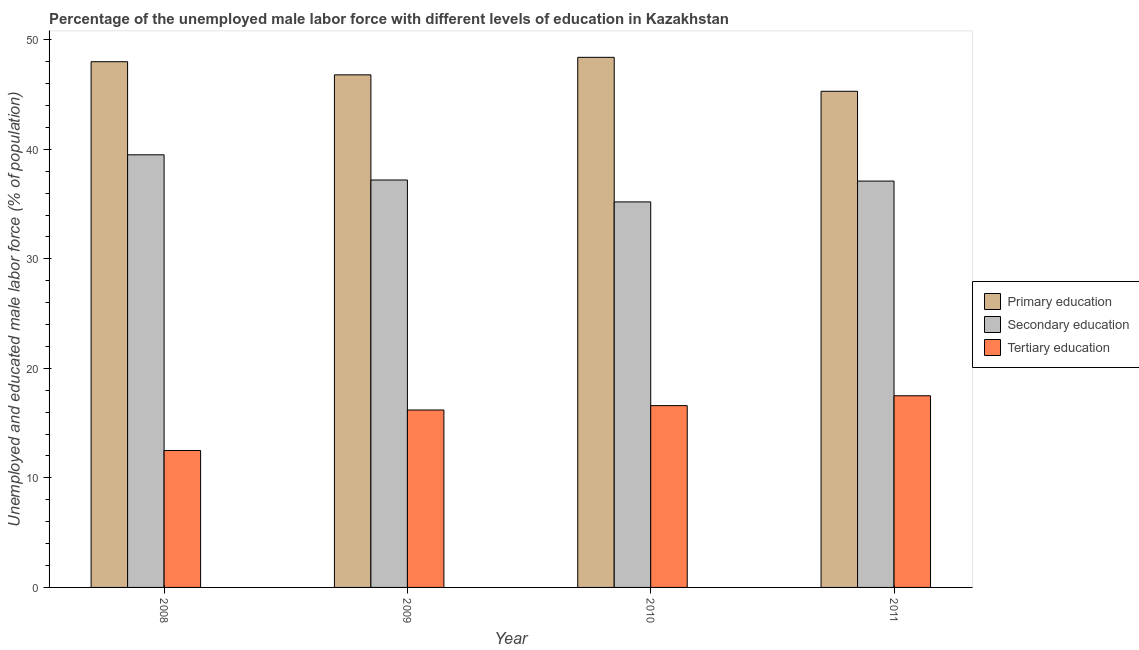How many different coloured bars are there?
Make the answer very short. 3. How many groups of bars are there?
Your answer should be very brief. 4. Are the number of bars per tick equal to the number of legend labels?
Offer a very short reply. Yes. How many bars are there on the 2nd tick from the left?
Your answer should be very brief. 3. How many bars are there on the 3rd tick from the right?
Offer a terse response. 3. In how many cases, is the number of bars for a given year not equal to the number of legend labels?
Your answer should be very brief. 0. What is the percentage of male labor force who received tertiary education in 2008?
Your response must be concise. 12.5. Across all years, what is the maximum percentage of male labor force who received tertiary education?
Ensure brevity in your answer.  17.5. Across all years, what is the minimum percentage of male labor force who received secondary education?
Your response must be concise. 35.2. What is the total percentage of male labor force who received primary education in the graph?
Your answer should be very brief. 188.5. What is the difference between the percentage of male labor force who received primary education in 2008 and that in 2009?
Ensure brevity in your answer.  1.2. What is the difference between the percentage of male labor force who received primary education in 2010 and the percentage of male labor force who received tertiary education in 2011?
Offer a terse response. 3.1. What is the average percentage of male labor force who received secondary education per year?
Ensure brevity in your answer.  37.25. What is the ratio of the percentage of male labor force who received tertiary education in 2009 to that in 2011?
Give a very brief answer. 0.93. Is the difference between the percentage of male labor force who received primary education in 2008 and 2011 greater than the difference between the percentage of male labor force who received tertiary education in 2008 and 2011?
Your answer should be compact. No. What is the difference between the highest and the second highest percentage of male labor force who received secondary education?
Provide a short and direct response. 2.3. What is the difference between the highest and the lowest percentage of male labor force who received secondary education?
Offer a very short reply. 4.3. What does the 3rd bar from the left in 2008 represents?
Ensure brevity in your answer.  Tertiary education. What does the 1st bar from the right in 2011 represents?
Make the answer very short. Tertiary education. Are all the bars in the graph horizontal?
Provide a succinct answer. No. How many years are there in the graph?
Provide a succinct answer. 4. Are the values on the major ticks of Y-axis written in scientific E-notation?
Ensure brevity in your answer.  No. Does the graph contain any zero values?
Make the answer very short. No. How are the legend labels stacked?
Your answer should be very brief. Vertical. What is the title of the graph?
Give a very brief answer. Percentage of the unemployed male labor force with different levels of education in Kazakhstan. Does "Wage workers" appear as one of the legend labels in the graph?
Ensure brevity in your answer.  No. What is the label or title of the X-axis?
Your answer should be very brief. Year. What is the label or title of the Y-axis?
Your answer should be very brief. Unemployed and educated male labor force (% of population). What is the Unemployed and educated male labor force (% of population) of Primary education in 2008?
Provide a succinct answer. 48. What is the Unemployed and educated male labor force (% of population) in Secondary education in 2008?
Ensure brevity in your answer.  39.5. What is the Unemployed and educated male labor force (% of population) in Tertiary education in 2008?
Give a very brief answer. 12.5. What is the Unemployed and educated male labor force (% of population) of Primary education in 2009?
Give a very brief answer. 46.8. What is the Unemployed and educated male labor force (% of population) of Secondary education in 2009?
Keep it short and to the point. 37.2. What is the Unemployed and educated male labor force (% of population) in Tertiary education in 2009?
Provide a succinct answer. 16.2. What is the Unemployed and educated male labor force (% of population) of Primary education in 2010?
Keep it short and to the point. 48.4. What is the Unemployed and educated male labor force (% of population) of Secondary education in 2010?
Your response must be concise. 35.2. What is the Unemployed and educated male labor force (% of population) of Tertiary education in 2010?
Your answer should be compact. 16.6. What is the Unemployed and educated male labor force (% of population) of Primary education in 2011?
Your answer should be very brief. 45.3. What is the Unemployed and educated male labor force (% of population) of Secondary education in 2011?
Give a very brief answer. 37.1. Across all years, what is the maximum Unemployed and educated male labor force (% of population) in Primary education?
Make the answer very short. 48.4. Across all years, what is the maximum Unemployed and educated male labor force (% of population) of Secondary education?
Provide a succinct answer. 39.5. Across all years, what is the minimum Unemployed and educated male labor force (% of population) in Primary education?
Keep it short and to the point. 45.3. Across all years, what is the minimum Unemployed and educated male labor force (% of population) in Secondary education?
Your response must be concise. 35.2. What is the total Unemployed and educated male labor force (% of population) in Primary education in the graph?
Your answer should be very brief. 188.5. What is the total Unemployed and educated male labor force (% of population) in Secondary education in the graph?
Give a very brief answer. 149. What is the total Unemployed and educated male labor force (% of population) of Tertiary education in the graph?
Keep it short and to the point. 62.8. What is the difference between the Unemployed and educated male labor force (% of population) in Tertiary education in 2008 and that in 2009?
Make the answer very short. -3.7. What is the difference between the Unemployed and educated male labor force (% of population) in Primary education in 2008 and that in 2010?
Offer a terse response. -0.4. What is the difference between the Unemployed and educated male labor force (% of population) of Tertiary education in 2008 and that in 2010?
Offer a terse response. -4.1. What is the difference between the Unemployed and educated male labor force (% of population) in Secondary education in 2008 and that in 2011?
Your answer should be compact. 2.4. What is the difference between the Unemployed and educated male labor force (% of population) in Tertiary education in 2008 and that in 2011?
Keep it short and to the point. -5. What is the difference between the Unemployed and educated male labor force (% of population) of Primary education in 2009 and that in 2010?
Make the answer very short. -1.6. What is the difference between the Unemployed and educated male labor force (% of population) of Primary education in 2009 and that in 2011?
Offer a terse response. 1.5. What is the difference between the Unemployed and educated male labor force (% of population) in Secondary education in 2009 and that in 2011?
Offer a terse response. 0.1. What is the difference between the Unemployed and educated male labor force (% of population) in Primary education in 2010 and that in 2011?
Offer a very short reply. 3.1. What is the difference between the Unemployed and educated male labor force (% of population) in Tertiary education in 2010 and that in 2011?
Provide a succinct answer. -0.9. What is the difference between the Unemployed and educated male labor force (% of population) in Primary education in 2008 and the Unemployed and educated male labor force (% of population) in Tertiary education in 2009?
Provide a short and direct response. 31.8. What is the difference between the Unemployed and educated male labor force (% of population) of Secondary education in 2008 and the Unemployed and educated male labor force (% of population) of Tertiary education in 2009?
Give a very brief answer. 23.3. What is the difference between the Unemployed and educated male labor force (% of population) in Primary education in 2008 and the Unemployed and educated male labor force (% of population) in Secondary education in 2010?
Make the answer very short. 12.8. What is the difference between the Unemployed and educated male labor force (% of population) of Primary education in 2008 and the Unemployed and educated male labor force (% of population) of Tertiary education in 2010?
Offer a very short reply. 31.4. What is the difference between the Unemployed and educated male labor force (% of population) in Secondary education in 2008 and the Unemployed and educated male labor force (% of population) in Tertiary education in 2010?
Make the answer very short. 22.9. What is the difference between the Unemployed and educated male labor force (% of population) in Primary education in 2008 and the Unemployed and educated male labor force (% of population) in Tertiary education in 2011?
Your response must be concise. 30.5. What is the difference between the Unemployed and educated male labor force (% of population) of Secondary education in 2008 and the Unemployed and educated male labor force (% of population) of Tertiary education in 2011?
Your answer should be compact. 22. What is the difference between the Unemployed and educated male labor force (% of population) in Primary education in 2009 and the Unemployed and educated male labor force (% of population) in Tertiary education in 2010?
Offer a terse response. 30.2. What is the difference between the Unemployed and educated male labor force (% of population) of Secondary education in 2009 and the Unemployed and educated male labor force (% of population) of Tertiary education in 2010?
Provide a succinct answer. 20.6. What is the difference between the Unemployed and educated male labor force (% of population) of Primary education in 2009 and the Unemployed and educated male labor force (% of population) of Secondary education in 2011?
Provide a succinct answer. 9.7. What is the difference between the Unemployed and educated male labor force (% of population) of Primary education in 2009 and the Unemployed and educated male labor force (% of population) of Tertiary education in 2011?
Ensure brevity in your answer.  29.3. What is the difference between the Unemployed and educated male labor force (% of population) in Secondary education in 2009 and the Unemployed and educated male labor force (% of population) in Tertiary education in 2011?
Ensure brevity in your answer.  19.7. What is the difference between the Unemployed and educated male labor force (% of population) of Primary education in 2010 and the Unemployed and educated male labor force (% of population) of Secondary education in 2011?
Offer a terse response. 11.3. What is the difference between the Unemployed and educated male labor force (% of population) of Primary education in 2010 and the Unemployed and educated male labor force (% of population) of Tertiary education in 2011?
Give a very brief answer. 30.9. What is the average Unemployed and educated male labor force (% of population) of Primary education per year?
Ensure brevity in your answer.  47.12. What is the average Unemployed and educated male labor force (% of population) in Secondary education per year?
Offer a terse response. 37.25. In the year 2008, what is the difference between the Unemployed and educated male labor force (% of population) of Primary education and Unemployed and educated male labor force (% of population) of Tertiary education?
Your answer should be very brief. 35.5. In the year 2008, what is the difference between the Unemployed and educated male labor force (% of population) of Secondary education and Unemployed and educated male labor force (% of population) of Tertiary education?
Offer a very short reply. 27. In the year 2009, what is the difference between the Unemployed and educated male labor force (% of population) in Primary education and Unemployed and educated male labor force (% of population) in Tertiary education?
Make the answer very short. 30.6. In the year 2010, what is the difference between the Unemployed and educated male labor force (% of population) of Primary education and Unemployed and educated male labor force (% of population) of Secondary education?
Offer a terse response. 13.2. In the year 2010, what is the difference between the Unemployed and educated male labor force (% of population) of Primary education and Unemployed and educated male labor force (% of population) of Tertiary education?
Provide a succinct answer. 31.8. In the year 2010, what is the difference between the Unemployed and educated male labor force (% of population) of Secondary education and Unemployed and educated male labor force (% of population) of Tertiary education?
Your response must be concise. 18.6. In the year 2011, what is the difference between the Unemployed and educated male labor force (% of population) in Primary education and Unemployed and educated male labor force (% of population) in Secondary education?
Make the answer very short. 8.2. In the year 2011, what is the difference between the Unemployed and educated male labor force (% of population) in Primary education and Unemployed and educated male labor force (% of population) in Tertiary education?
Your answer should be compact. 27.8. In the year 2011, what is the difference between the Unemployed and educated male labor force (% of population) in Secondary education and Unemployed and educated male labor force (% of population) in Tertiary education?
Offer a very short reply. 19.6. What is the ratio of the Unemployed and educated male labor force (% of population) in Primary education in 2008 to that in 2009?
Your answer should be very brief. 1.03. What is the ratio of the Unemployed and educated male labor force (% of population) in Secondary education in 2008 to that in 2009?
Give a very brief answer. 1.06. What is the ratio of the Unemployed and educated male labor force (% of population) of Tertiary education in 2008 to that in 2009?
Make the answer very short. 0.77. What is the ratio of the Unemployed and educated male labor force (% of population) of Primary education in 2008 to that in 2010?
Your answer should be compact. 0.99. What is the ratio of the Unemployed and educated male labor force (% of population) in Secondary education in 2008 to that in 2010?
Offer a terse response. 1.12. What is the ratio of the Unemployed and educated male labor force (% of population) of Tertiary education in 2008 to that in 2010?
Your answer should be compact. 0.75. What is the ratio of the Unemployed and educated male labor force (% of population) in Primary education in 2008 to that in 2011?
Ensure brevity in your answer.  1.06. What is the ratio of the Unemployed and educated male labor force (% of population) of Secondary education in 2008 to that in 2011?
Your response must be concise. 1.06. What is the ratio of the Unemployed and educated male labor force (% of population) of Tertiary education in 2008 to that in 2011?
Ensure brevity in your answer.  0.71. What is the ratio of the Unemployed and educated male labor force (% of population) in Primary education in 2009 to that in 2010?
Your response must be concise. 0.97. What is the ratio of the Unemployed and educated male labor force (% of population) in Secondary education in 2009 to that in 2010?
Your response must be concise. 1.06. What is the ratio of the Unemployed and educated male labor force (% of population) of Tertiary education in 2009 to that in 2010?
Offer a terse response. 0.98. What is the ratio of the Unemployed and educated male labor force (% of population) in Primary education in 2009 to that in 2011?
Provide a short and direct response. 1.03. What is the ratio of the Unemployed and educated male labor force (% of population) of Secondary education in 2009 to that in 2011?
Make the answer very short. 1. What is the ratio of the Unemployed and educated male labor force (% of population) in Tertiary education in 2009 to that in 2011?
Give a very brief answer. 0.93. What is the ratio of the Unemployed and educated male labor force (% of population) in Primary education in 2010 to that in 2011?
Ensure brevity in your answer.  1.07. What is the ratio of the Unemployed and educated male labor force (% of population) in Secondary education in 2010 to that in 2011?
Your response must be concise. 0.95. What is the ratio of the Unemployed and educated male labor force (% of population) of Tertiary education in 2010 to that in 2011?
Your answer should be compact. 0.95. What is the difference between the highest and the second highest Unemployed and educated male labor force (% of population) in Primary education?
Give a very brief answer. 0.4. What is the difference between the highest and the second highest Unemployed and educated male labor force (% of population) in Tertiary education?
Your answer should be very brief. 0.9. What is the difference between the highest and the lowest Unemployed and educated male labor force (% of population) of Primary education?
Your answer should be very brief. 3.1. 